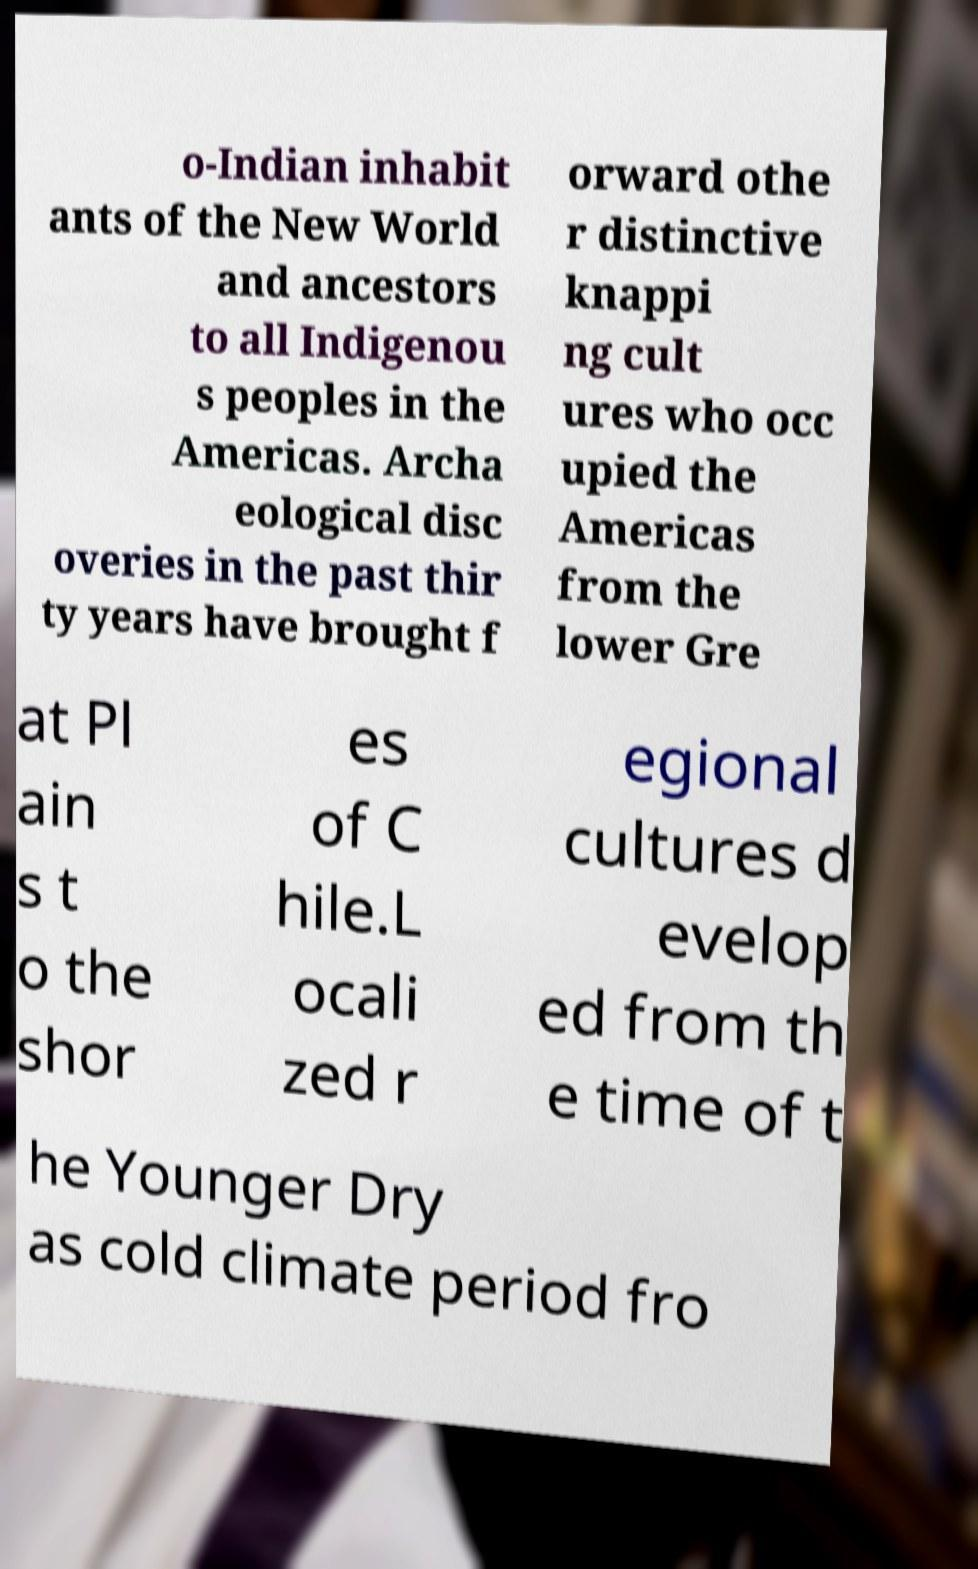I need the written content from this picture converted into text. Can you do that? o-Indian inhabit ants of the New World and ancestors to all Indigenou s peoples in the Americas. Archa eological disc overies in the past thir ty years have brought f orward othe r distinctive knappi ng cult ures who occ upied the Americas from the lower Gre at Pl ain s t o the shor es of C hile.L ocali zed r egional cultures d evelop ed from th e time of t he Younger Dry as cold climate period fro 